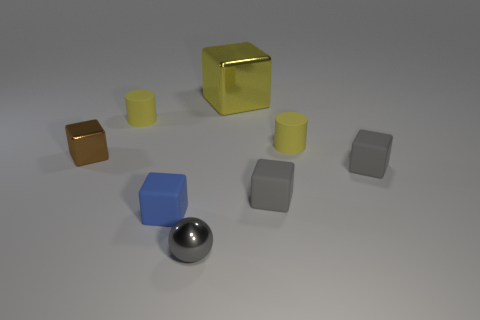Is there a tiny cylinder that has the same color as the big metallic block?
Your answer should be compact. Yes. Is the color of the tiny cylinder that is on the right side of the tiny metal ball the same as the tiny cylinder that is left of the tiny metallic sphere?
Your answer should be very brief. Yes. What is the material of the large block behind the tiny blue rubber block?
Give a very brief answer. Metal. What color is the sphere that is made of the same material as the large cube?
Offer a terse response. Gray. What number of shiny things have the same size as the blue matte object?
Offer a very short reply. 2. There is a metallic thing behind the brown metal block; does it have the same size as the small gray metal thing?
Your answer should be very brief. No. There is a metal object that is behind the blue rubber object and in front of the yellow shiny block; what is its shape?
Provide a succinct answer. Cube. There is a small metal ball; are there any shiny things to the left of it?
Make the answer very short. Yes. Are there any other things that have the same shape as the small gray metallic object?
Offer a terse response. No. Do the small blue matte thing and the big thing have the same shape?
Provide a succinct answer. Yes. 